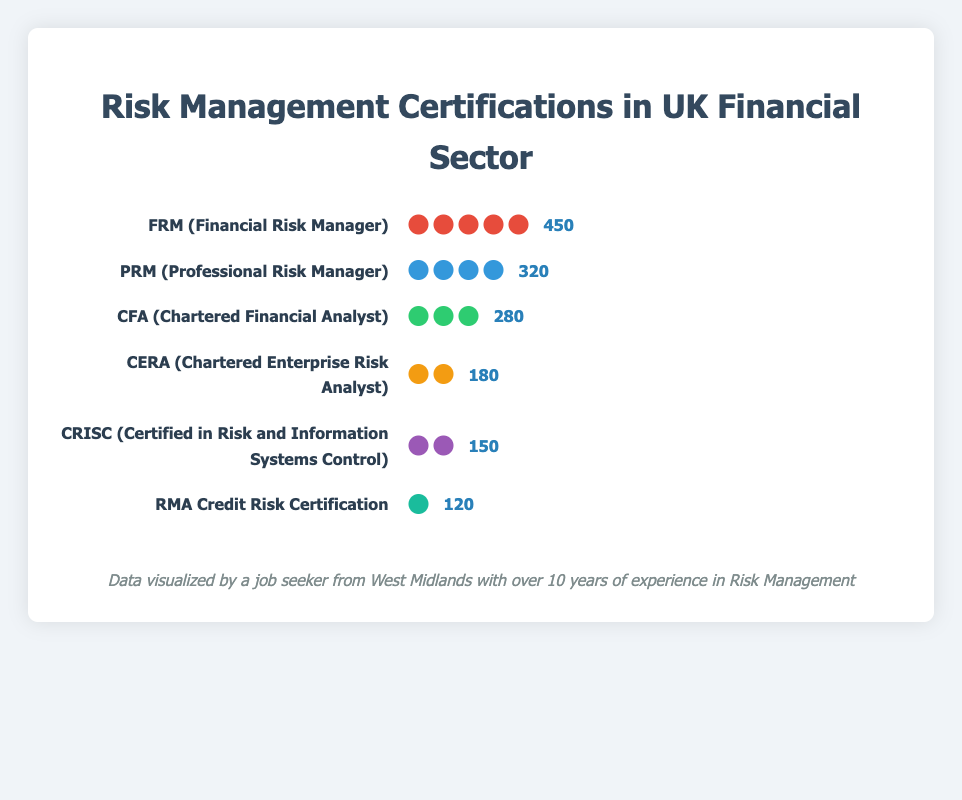what are the top three certifications by count? To identify the top three certifications by count, we examine the bars in the figure. The longest bars correspond to the highest counts. FRM, PRM, and CFA have the longest bars, respectively.
Answer: FRM, PRM, CFA how many more FRM professionals are there compared to PRM professionals? To find the difference in the number of professionals with FRM and PRM certifications, subtract the count of PRM (320) from the count of FRM (450).
Answer: 130 how many total professionals hold the listed risk management certifications? Sum the count of professionals for all six certifications: FRM (450), PRM (320), CFA (280), CERA (180), CRISC (150), and RMA (120). Adding them gives 1500.
Answer: 1500 which certification has the least number of professionals? To identify the certification with the least number of professionals, find the shortest bar in the figure. RMA has the shortest bar with a count of 120.
Answer: RMA which certifications have a count of fewer than 200 professionals? Scan for bars with labels and counts showing fewer than 200 professionals. CERA (180) and CRISC (150) are the ones below 200.
Answer: CERA, CRISC is the count of CFA certified professionals closer to CRISC or PRM? Compare the counts of CFA (280), CRISC (150), and PRM (320). The difference between CFA and CRISC is 130, and the difference between CFA and PRM is 40. Thus, CFA is closer to PRM.
Answer: PRM what percentage of the certifications does the FRM certification represent? To determine the percentage, divide the count of FRM (450) by the total count of all certifications (1500) and multiply by 100. (450/1500) * 100 = 30%.
Answer: 30% how many icons are used to represent the CFA certification? Each icon in the bar chart represents a portion of the count for each certification. For CFA, there are 3 icons displayed.
Answer: 3 what is the difference in count between the CFA and CERA certifications? Subtract the count of CERA (180) from the count of CFA (280) to get the difference. 280 - 180 = 100.
Answer: 100 which certification has a more colorful representation in the chart: PRM or CRISC? PRM is represented by blue-colored icons, while CRISC is represented by purple-colored icons. Since both have a single color, neither is more colorful than the other.
Answer: Neither 